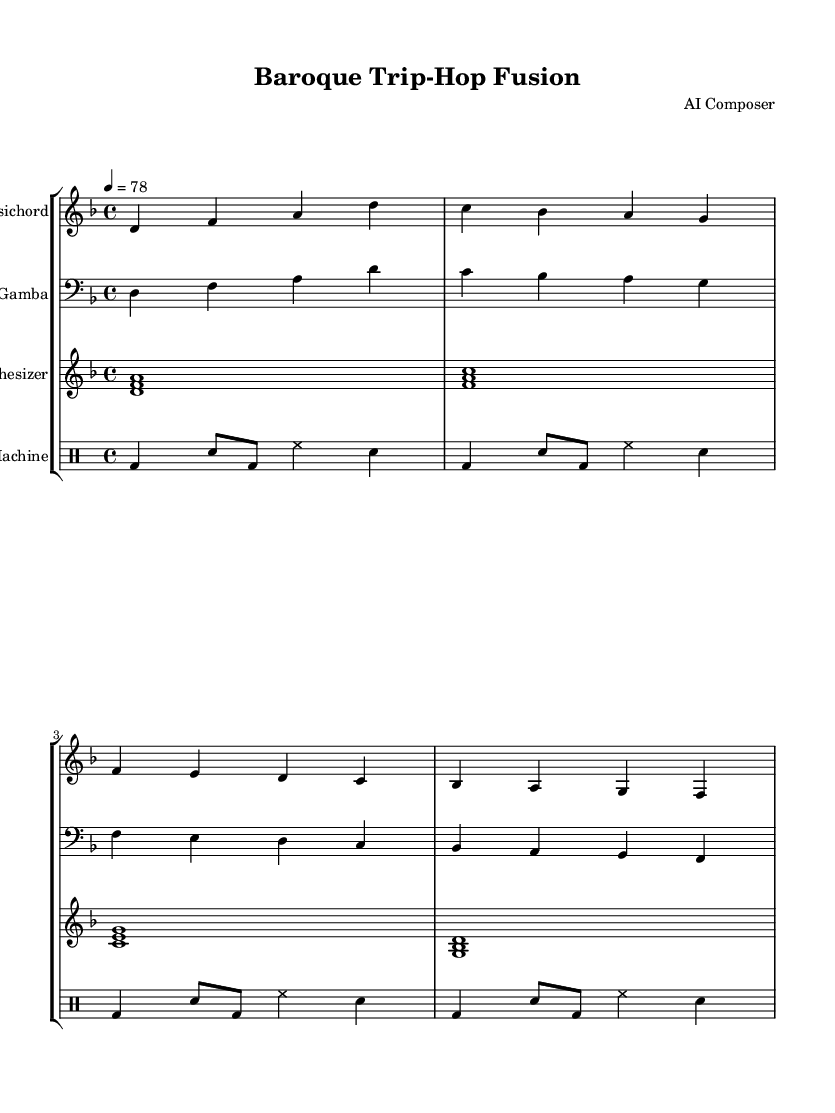What is the key signature of this music? The key signature is indicated at the beginning of the piece. It shows two flats, which correspond to the key of D minor.
Answer: D minor What is the time signature of this music? The time signature is placed at the beginning of the score, represented by a "4/4." This indicates that there are four beats in each measure and a quarter note receives one beat.
Answer: 4/4 What is the tempo marking for the composition? The tempo marking is found at the top of the score, showing "4 = 78," meaning the quarter note is to be played at a speed of 78 beats per minute.
Answer: 78 How many instruments are used in this composition? The score lists four distinct staves for instruments: Harpsichord, Viola da Gamba, Synthesizer, and Drum Machine. Thus, there are four instruments in total.
Answer: Four What type of ensemble is this music written for? The presence of both traditional Baroque instruments (Harpsichord and Viola da Gamba) and modern elements like Synthesizer and Drum Machine indicates a fusion ensemble.
Answer: Fusion ensemble Which rhythmic style does the drum machine section depict? The drum machine employs a combination of bass drum, snare, and hi-hat patterns, aligned with typical trip-hop rhythms characterized by irregular beats and syncopation.
Answer: Trip-hop What distinguishes the synthesizer part from the traditional parts? The synthesizer part features chordal harmonies played as whole notes, contrasting the more intricate, contrapuntal lines typical of the Baroque style found in the Harpsichord and Viola da Gamba parts.
Answer: Chordal harmonies 